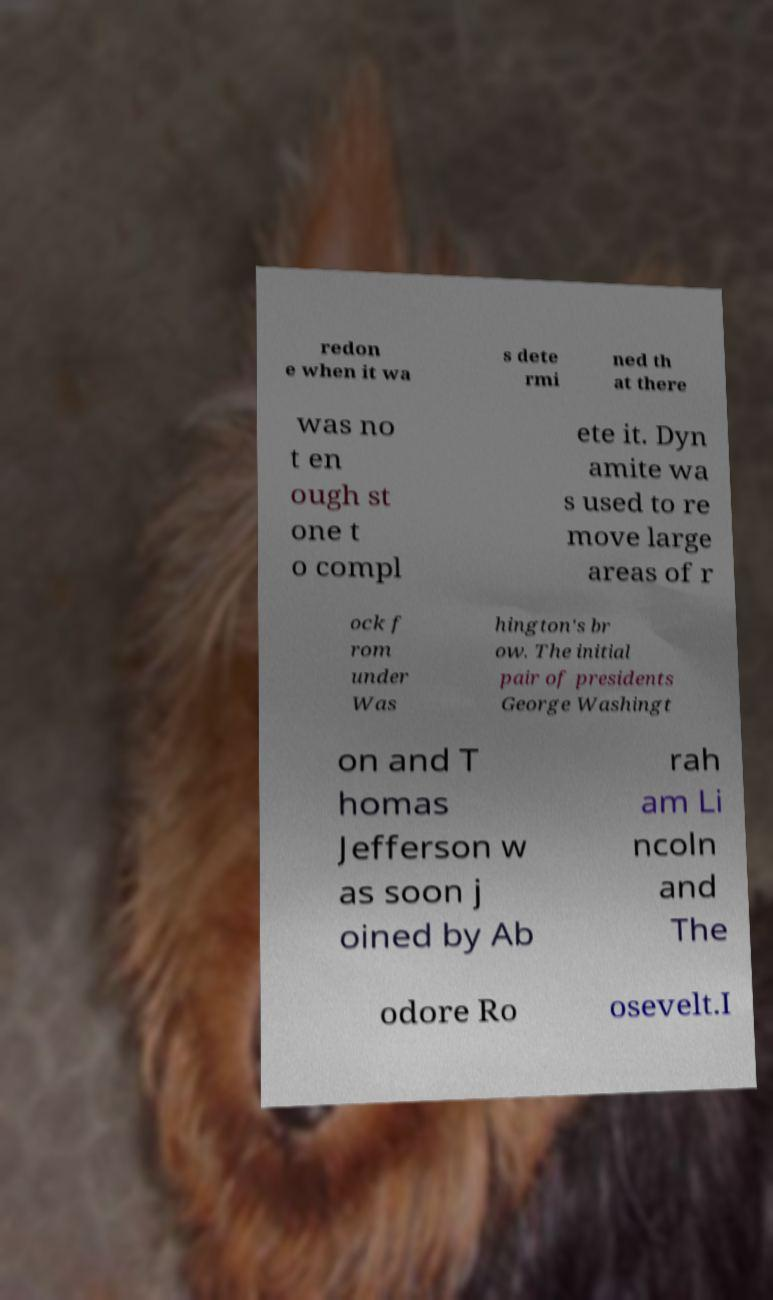Can you read and provide the text displayed in the image?This photo seems to have some interesting text. Can you extract and type it out for me? redon e when it wa s dete rmi ned th at there was no t en ough st one t o compl ete it. Dyn amite wa s used to re move large areas of r ock f rom under Was hington's br ow. The initial pair of presidents George Washingt on and T homas Jefferson w as soon j oined by Ab rah am Li ncoln and The odore Ro osevelt.I 